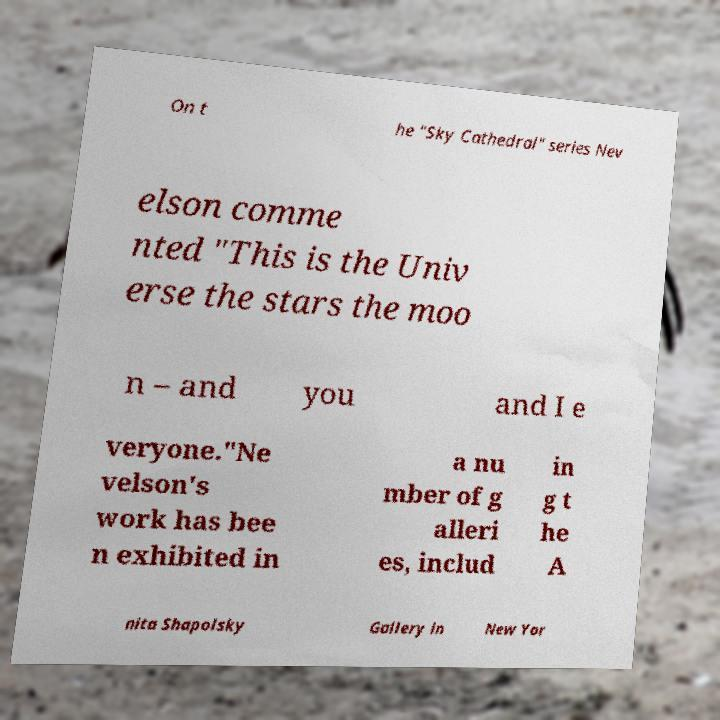Can you read and provide the text displayed in the image?This photo seems to have some interesting text. Can you extract and type it out for me? On t he "Sky Cathedral" series Nev elson comme nted "This is the Univ erse the stars the moo n – and you and I e veryone."Ne velson's work has bee n exhibited in a nu mber of g alleri es, includ in g t he A nita Shapolsky Gallery in New Yor 